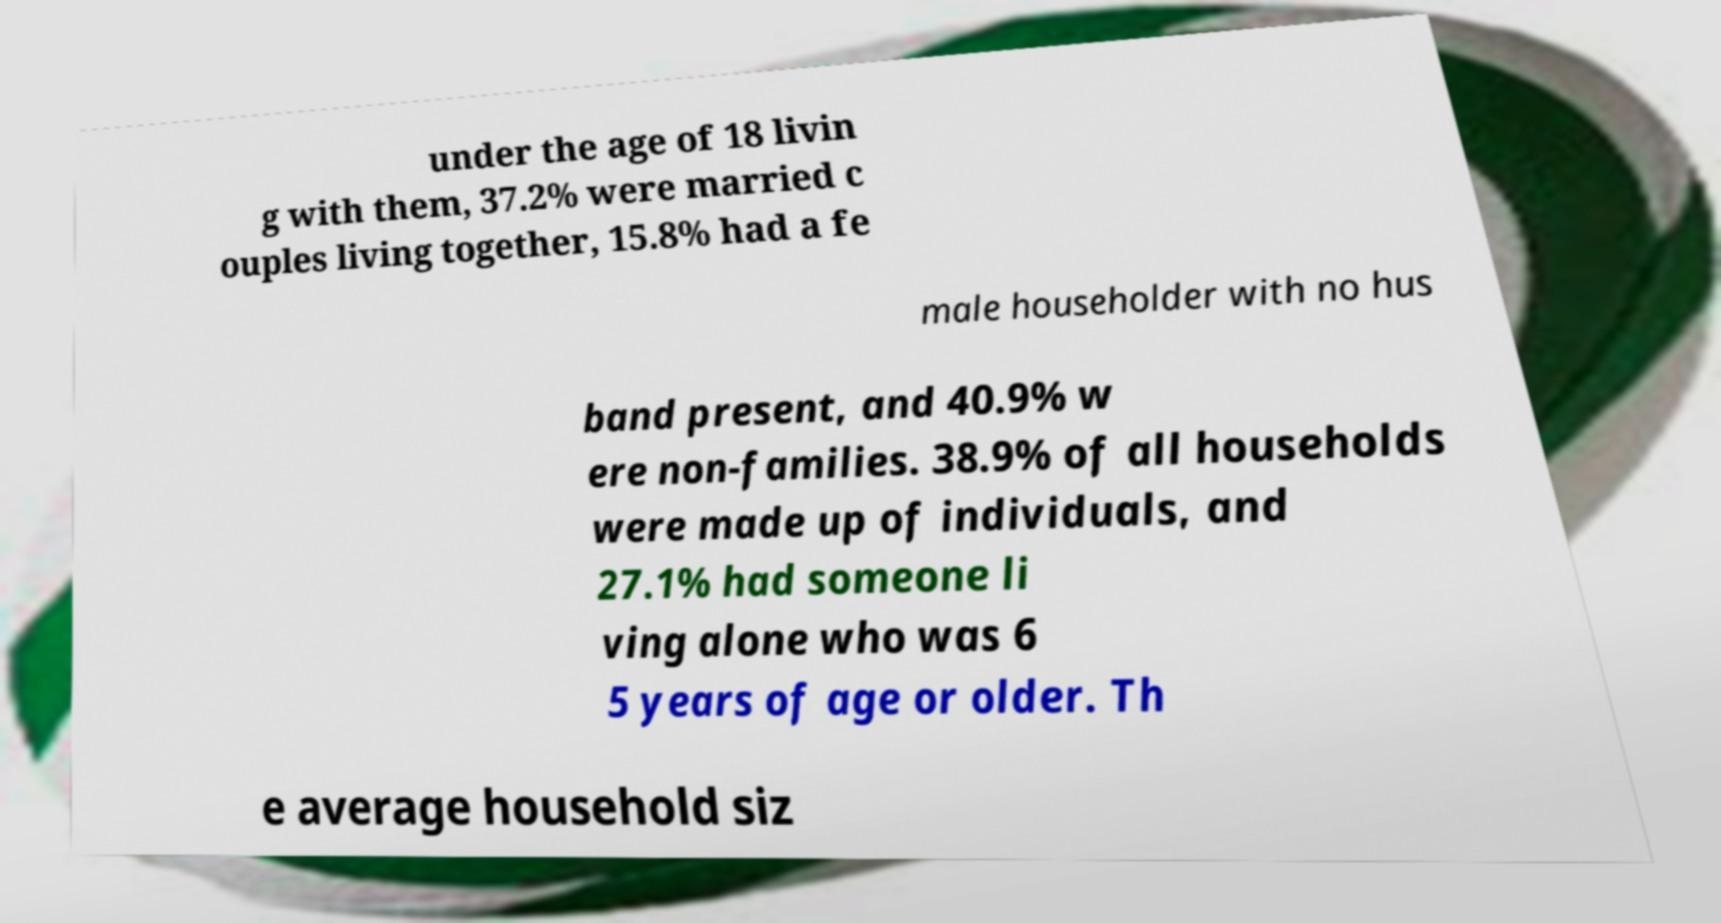Could you extract and type out the text from this image? under the age of 18 livin g with them, 37.2% were married c ouples living together, 15.8% had a fe male householder with no hus band present, and 40.9% w ere non-families. 38.9% of all households were made up of individuals, and 27.1% had someone li ving alone who was 6 5 years of age or older. Th e average household siz 